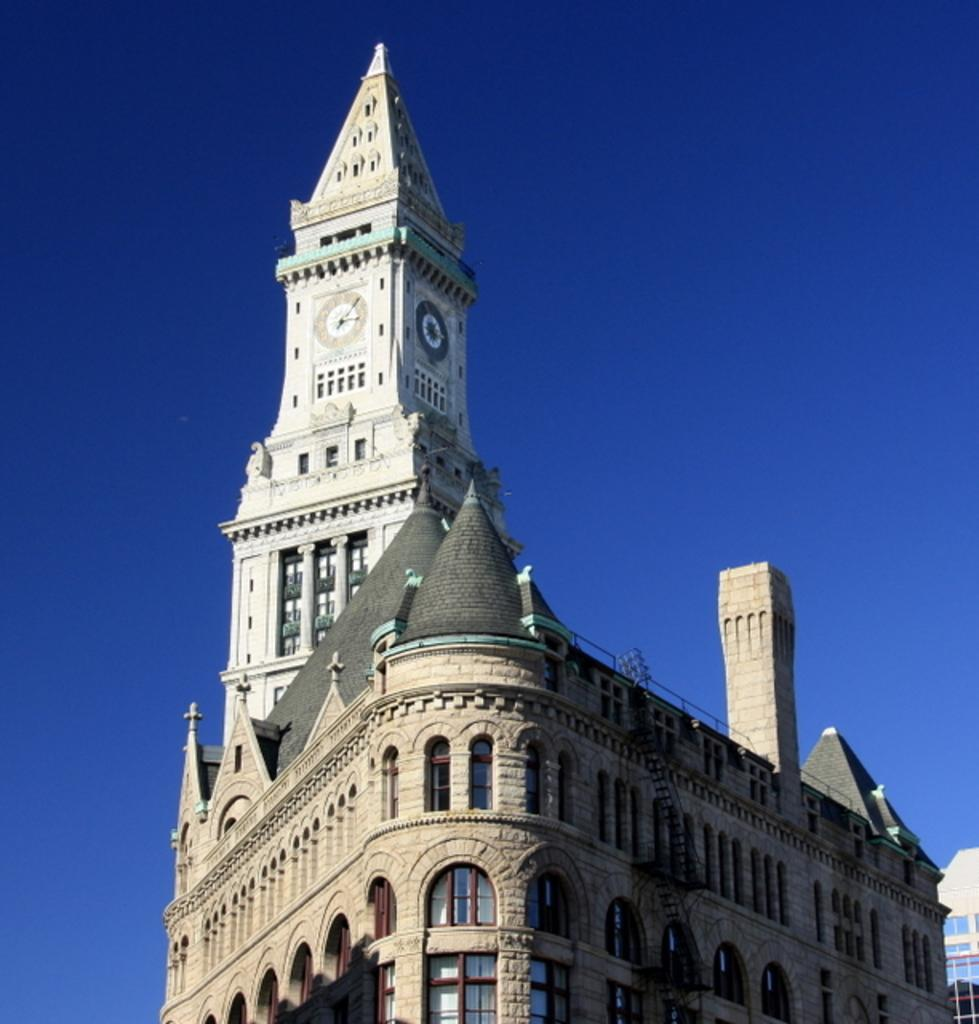What type of structure is present in the image? There is a building in the image. What specific feature can be seen on the building? The building has a clock tower. What can be seen in the distance behind the building? There is a sky visible in the background of the image. Are there any caves visible in the image? No, there are no caves present in the image. What type of trade is being conducted in the image? There is no trade being conducted in the image; it only features a building with a clock tower and a sky in the background. 